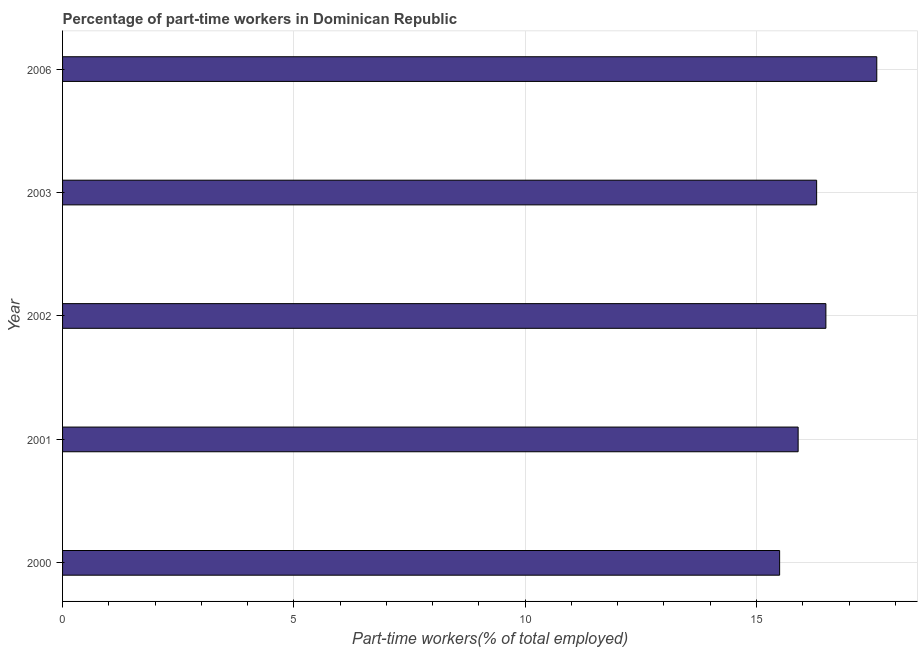Does the graph contain grids?
Offer a very short reply. Yes. What is the title of the graph?
Offer a terse response. Percentage of part-time workers in Dominican Republic. What is the label or title of the X-axis?
Provide a succinct answer. Part-time workers(% of total employed). What is the label or title of the Y-axis?
Give a very brief answer. Year. What is the percentage of part-time workers in 2000?
Give a very brief answer. 15.5. Across all years, what is the maximum percentage of part-time workers?
Keep it short and to the point. 17.6. In which year was the percentage of part-time workers minimum?
Provide a short and direct response. 2000. What is the sum of the percentage of part-time workers?
Offer a very short reply. 81.8. What is the average percentage of part-time workers per year?
Provide a succinct answer. 16.36. What is the median percentage of part-time workers?
Your answer should be very brief. 16.3. Do a majority of the years between 2001 and 2006 (inclusive) have percentage of part-time workers greater than 10 %?
Provide a succinct answer. Yes. Is the percentage of part-time workers in 2003 less than that in 2006?
Provide a short and direct response. Yes. Is the difference between the percentage of part-time workers in 2003 and 2006 greater than the difference between any two years?
Your answer should be compact. No. Is the sum of the percentage of part-time workers in 2001 and 2003 greater than the maximum percentage of part-time workers across all years?
Make the answer very short. Yes. In how many years, is the percentage of part-time workers greater than the average percentage of part-time workers taken over all years?
Your answer should be compact. 2. How many bars are there?
Ensure brevity in your answer.  5. How many years are there in the graph?
Ensure brevity in your answer.  5. What is the Part-time workers(% of total employed) of 2000?
Your answer should be compact. 15.5. What is the Part-time workers(% of total employed) of 2001?
Your answer should be very brief. 15.9. What is the Part-time workers(% of total employed) in 2002?
Ensure brevity in your answer.  16.5. What is the Part-time workers(% of total employed) of 2003?
Your answer should be very brief. 16.3. What is the Part-time workers(% of total employed) in 2006?
Offer a terse response. 17.6. What is the difference between the Part-time workers(% of total employed) in 2000 and 2003?
Your answer should be compact. -0.8. What is the difference between the Part-time workers(% of total employed) in 2001 and 2002?
Offer a terse response. -0.6. What is the difference between the Part-time workers(% of total employed) in 2001 and 2003?
Offer a terse response. -0.4. What is the difference between the Part-time workers(% of total employed) in 2001 and 2006?
Your response must be concise. -1.7. What is the difference between the Part-time workers(% of total employed) in 2002 and 2003?
Your answer should be compact. 0.2. What is the ratio of the Part-time workers(% of total employed) in 2000 to that in 2002?
Provide a short and direct response. 0.94. What is the ratio of the Part-time workers(% of total employed) in 2000 to that in 2003?
Your response must be concise. 0.95. What is the ratio of the Part-time workers(% of total employed) in 2000 to that in 2006?
Offer a very short reply. 0.88. What is the ratio of the Part-time workers(% of total employed) in 2001 to that in 2002?
Your answer should be very brief. 0.96. What is the ratio of the Part-time workers(% of total employed) in 2001 to that in 2006?
Your response must be concise. 0.9. What is the ratio of the Part-time workers(% of total employed) in 2002 to that in 2003?
Provide a short and direct response. 1.01. What is the ratio of the Part-time workers(% of total employed) in 2002 to that in 2006?
Your response must be concise. 0.94. What is the ratio of the Part-time workers(% of total employed) in 2003 to that in 2006?
Give a very brief answer. 0.93. 